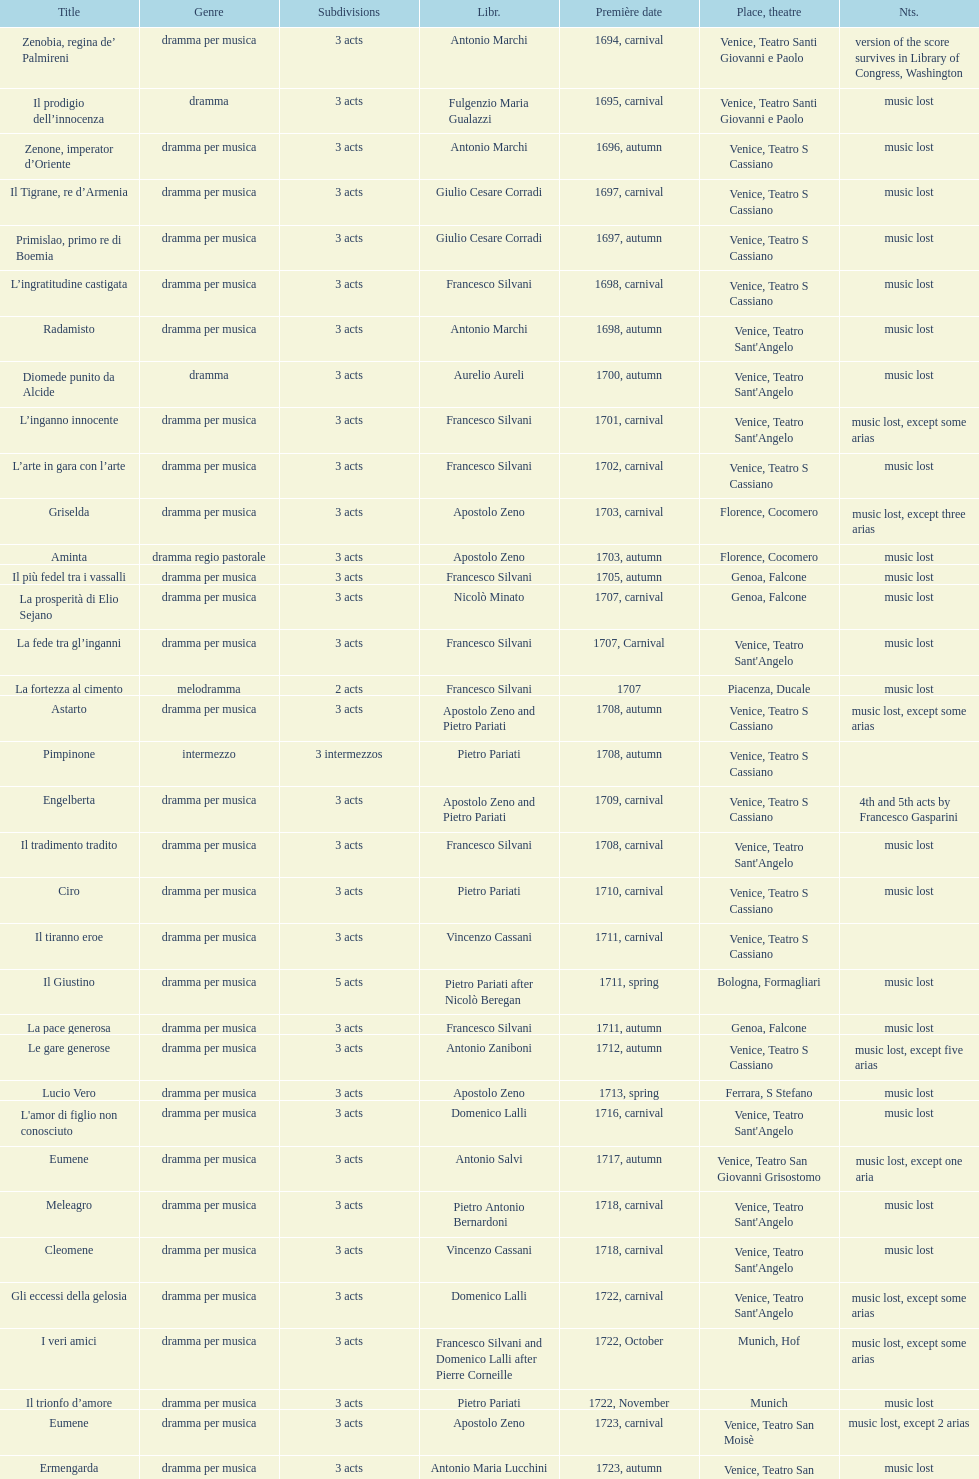Could you parse the entire table as a dict? {'header': ['Title', 'Genre', 'Subdivisions', 'Libr.', 'Première date', 'Place, theatre', 'Nts.'], 'rows': [['Zenobia, regina de’ Palmireni', 'dramma per musica', '3 acts', 'Antonio Marchi', '1694, carnival', 'Venice, Teatro Santi Giovanni e Paolo', 'version of the score survives in Library of Congress, Washington'], ['Il prodigio dell’innocenza', 'dramma', '3 acts', 'Fulgenzio Maria Gualazzi', '1695, carnival', 'Venice, Teatro Santi Giovanni e Paolo', 'music lost'], ['Zenone, imperator d’Oriente', 'dramma per musica', '3 acts', 'Antonio Marchi', '1696, autumn', 'Venice, Teatro S Cassiano', 'music lost'], ['Il Tigrane, re d’Armenia', 'dramma per musica', '3 acts', 'Giulio Cesare Corradi', '1697, carnival', 'Venice, Teatro S Cassiano', 'music lost'], ['Primislao, primo re di Boemia', 'dramma per musica', '3 acts', 'Giulio Cesare Corradi', '1697, autumn', 'Venice, Teatro S Cassiano', 'music lost'], ['L’ingratitudine castigata', 'dramma per musica', '3 acts', 'Francesco Silvani', '1698, carnival', 'Venice, Teatro S Cassiano', 'music lost'], ['Radamisto', 'dramma per musica', '3 acts', 'Antonio Marchi', '1698, autumn', "Venice, Teatro Sant'Angelo", 'music lost'], ['Diomede punito da Alcide', 'dramma', '3 acts', 'Aurelio Aureli', '1700, autumn', "Venice, Teatro Sant'Angelo", 'music lost'], ['L’inganno innocente', 'dramma per musica', '3 acts', 'Francesco Silvani', '1701, carnival', "Venice, Teatro Sant'Angelo", 'music lost, except some arias'], ['L’arte in gara con l’arte', 'dramma per musica', '3 acts', 'Francesco Silvani', '1702, carnival', 'Venice, Teatro S Cassiano', 'music lost'], ['Griselda', 'dramma per musica', '3 acts', 'Apostolo Zeno', '1703, carnival', 'Florence, Cocomero', 'music lost, except three arias'], ['Aminta', 'dramma regio pastorale', '3 acts', 'Apostolo Zeno', '1703, autumn', 'Florence, Cocomero', 'music lost'], ['Il più fedel tra i vassalli', 'dramma per musica', '3 acts', 'Francesco Silvani', '1705, autumn', 'Genoa, Falcone', 'music lost'], ['La prosperità di Elio Sejano', 'dramma per musica', '3 acts', 'Nicolò Minato', '1707, carnival', 'Genoa, Falcone', 'music lost'], ['La fede tra gl’inganni', 'dramma per musica', '3 acts', 'Francesco Silvani', '1707, Carnival', "Venice, Teatro Sant'Angelo", 'music lost'], ['La fortezza al cimento', 'melodramma', '2 acts', 'Francesco Silvani', '1707', 'Piacenza, Ducale', 'music lost'], ['Astarto', 'dramma per musica', '3 acts', 'Apostolo Zeno and Pietro Pariati', '1708, autumn', 'Venice, Teatro S Cassiano', 'music lost, except some arias'], ['Pimpinone', 'intermezzo', '3 intermezzos', 'Pietro Pariati', '1708, autumn', 'Venice, Teatro S Cassiano', ''], ['Engelberta', 'dramma per musica', '3 acts', 'Apostolo Zeno and Pietro Pariati', '1709, carnival', 'Venice, Teatro S Cassiano', '4th and 5th acts by Francesco Gasparini'], ['Il tradimento tradito', 'dramma per musica', '3 acts', 'Francesco Silvani', '1708, carnival', "Venice, Teatro Sant'Angelo", 'music lost'], ['Ciro', 'dramma per musica', '3 acts', 'Pietro Pariati', '1710, carnival', 'Venice, Teatro S Cassiano', 'music lost'], ['Il tiranno eroe', 'dramma per musica', '3 acts', 'Vincenzo Cassani', '1711, carnival', 'Venice, Teatro S Cassiano', ''], ['Il Giustino', 'dramma per musica', '5 acts', 'Pietro Pariati after Nicolò Beregan', '1711, spring', 'Bologna, Formagliari', 'music lost'], ['La pace generosa', 'dramma per musica', '3 acts', 'Francesco Silvani', '1711, autumn', 'Genoa, Falcone', 'music lost'], ['Le gare generose', 'dramma per musica', '3 acts', 'Antonio Zaniboni', '1712, autumn', 'Venice, Teatro S Cassiano', 'music lost, except five arias'], ['Lucio Vero', 'dramma per musica', '3 acts', 'Apostolo Zeno', '1713, spring', 'Ferrara, S Stefano', 'music lost'], ["L'amor di figlio non conosciuto", 'dramma per musica', '3 acts', 'Domenico Lalli', '1716, carnival', "Venice, Teatro Sant'Angelo", 'music lost'], ['Eumene', 'dramma per musica', '3 acts', 'Antonio Salvi', '1717, autumn', 'Venice, Teatro San Giovanni Grisostomo', 'music lost, except one aria'], ['Meleagro', 'dramma per musica', '3 acts', 'Pietro Antonio Bernardoni', '1718, carnival', "Venice, Teatro Sant'Angelo", 'music lost'], ['Cleomene', 'dramma per musica', '3 acts', 'Vincenzo Cassani', '1718, carnival', "Venice, Teatro Sant'Angelo", 'music lost'], ['Gli eccessi della gelosia', 'dramma per musica', '3 acts', 'Domenico Lalli', '1722, carnival', "Venice, Teatro Sant'Angelo", 'music lost, except some arias'], ['I veri amici', 'dramma per musica', '3 acts', 'Francesco Silvani and Domenico Lalli after Pierre Corneille', '1722, October', 'Munich, Hof', 'music lost, except some arias'], ['Il trionfo d’amore', 'dramma per musica', '3 acts', 'Pietro Pariati', '1722, November', 'Munich', 'music lost'], ['Eumene', 'dramma per musica', '3 acts', 'Apostolo Zeno', '1723, carnival', 'Venice, Teatro San Moisè', 'music lost, except 2 arias'], ['Ermengarda', 'dramma per musica', '3 acts', 'Antonio Maria Lucchini', '1723, autumn', 'Venice, Teatro San Moisè', 'music lost'], ['Antigono, tutore di Filippo, re di Macedonia', 'tragedia', '5 acts', 'Giovanni Piazzon', '1724, carnival', 'Venice, Teatro San Moisè', '5th act by Giovanni Porta, music lost'], ['Scipione nelle Spagne', 'dramma per musica', '3 acts', 'Apostolo Zeno', '1724, Ascension', 'Venice, Teatro San Samuele', 'music lost'], ['Laodice', 'dramma per musica', '3 acts', 'Angelo Schietti', '1724, autumn', 'Venice, Teatro San Moisè', 'music lost, except 2 arias'], ['Didone abbandonata', 'tragedia', '3 acts', 'Metastasio', '1725, carnival', 'Venice, Teatro S Cassiano', 'music lost'], ["L'impresario delle Isole Canarie", 'intermezzo', '2 acts', 'Metastasio', '1725, carnival', 'Venice, Teatro S Cassiano', 'music lost'], ['Alcina delusa da Ruggero', 'dramma per musica', '3 acts', 'Antonio Marchi', '1725, autumn', 'Venice, Teatro S Cassiano', 'music lost'], ['I rivali generosi', 'dramma per musica', '3 acts', 'Apostolo Zeno', '1725', 'Brescia, Nuovo', ''], ['La Statira', 'dramma per musica', '3 acts', 'Apostolo Zeno and Pietro Pariati', '1726, Carnival', 'Rome, Teatro Capranica', ''], ['Malsazio e Fiammetta', 'intermezzo', '', '', '1726, Carnival', 'Rome, Teatro Capranica', ''], ['Il trionfo di Armida', 'dramma per musica', '3 acts', 'Girolamo Colatelli after Torquato Tasso', '1726, autumn', 'Venice, Teatro San Moisè', 'music lost'], ['L’incostanza schernita', 'dramma comico-pastorale', '3 acts', 'Vincenzo Cassani', '1727, Ascension', 'Venice, Teatro San Samuele', 'music lost, except some arias'], ['Le due rivali in amore', 'dramma per musica', '3 acts', 'Aurelio Aureli', '1728, autumn', 'Venice, Teatro San Moisè', 'music lost'], ['Il Satrapone', 'intermezzo', '', 'Salvi', '1729', 'Parma, Omodeo', ''], ['Li stratagemmi amorosi', 'dramma per musica', '3 acts', 'F Passerini', '1730, carnival', 'Venice, Teatro San Moisè', 'music lost'], ['Elenia', 'dramma per musica', '3 acts', 'Luisa Bergalli', '1730, carnival', "Venice, Teatro Sant'Angelo", 'music lost'], ['Merope', 'dramma', '3 acts', 'Apostolo Zeno', '1731, autumn', 'Prague, Sporck Theater', 'mostly by Albinoni, music lost'], ['Il più infedel tra gli amanti', 'dramma per musica', '3 acts', 'Angelo Schietti', '1731, autumn', 'Treviso, Dolphin', 'music lost'], ['Ardelinda', 'dramma', '3 acts', 'Bartolomeo Vitturi', '1732, autumn', "Venice, Teatro Sant'Angelo", 'music lost, except five arias'], ['Candalide', 'dramma per musica', '3 acts', 'Bartolomeo Vitturi', '1734, carnival', "Venice, Teatro Sant'Angelo", 'music lost'], ['Artamene', 'dramma per musica', '3 acts', 'Bartolomeo Vitturi', '1741, carnival', "Venice, Teatro Sant'Angelo", 'music lost']]} How many operas on this list has at least 3 acts? 51. 